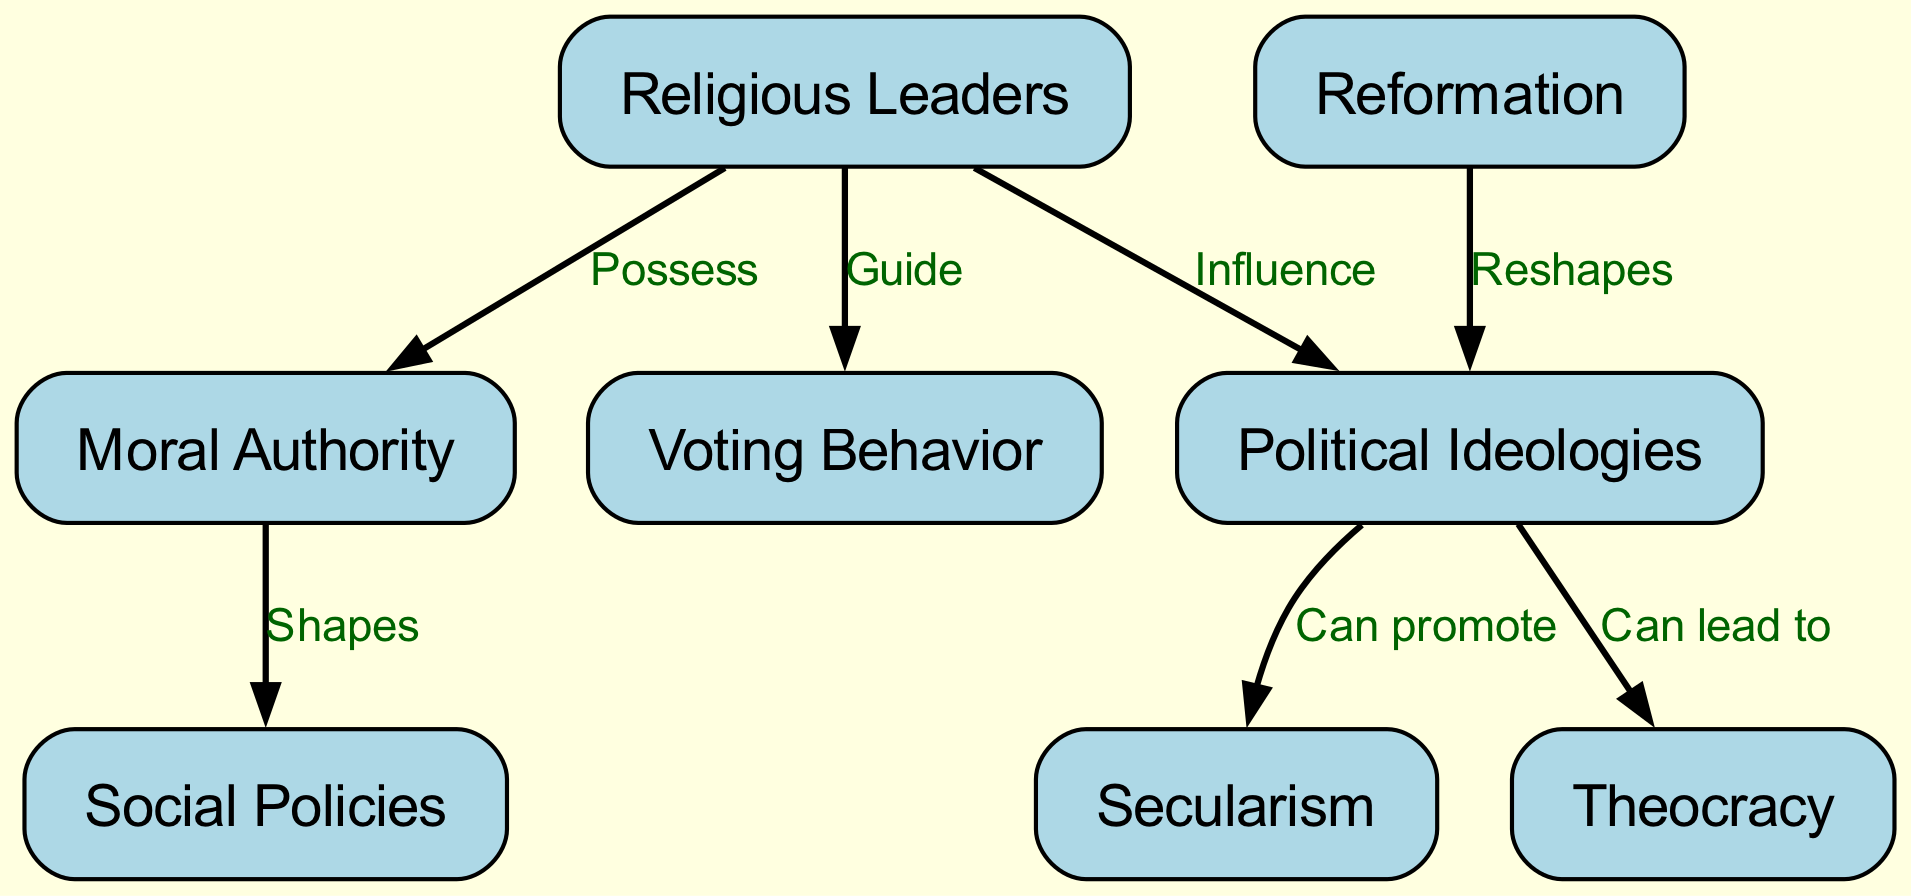What is the main type of influence religious leaders have on political ideologies? The diagram indicates that religious leaders have an "Influence" on political ideologies, showing their ability to shape or direct how ideologies form and evolve within a society.
Answer: Influence How many nodes are present in the diagram? Counting the nodes listed, there are 8 distinct entities represented in the diagram.
Answer: 8 Which political ideology can lead to theocracy? The diagram clearly illustrates that one of the political ideologies is theocracy, linked by the label "Can lead to" from the political ideologies node.
Answer: Theocracy What do religious leaders possess according to the diagram? The diagram explicitly states that religious leaders "Possess" moral authority, indicating their recognized status and influence in ethical and governance discussions.
Answer: Moral Authority How do moral authority and social policies relate? The arrow between "Moral Authority" and "Social Policies" labeled "Shapes" indicates that moral authority can influence or determine the nature of social policies in a political context.
Answer: Shapes What role do religious leaders play in voting behavior? According to the diagram, religious leaders "Guide" voting behavior, showcasing their essential impact on how individuals make choices during elections, often aligned with religious values.
Answer: Guide What can political ideologies promote according to the diagram? The diagram shows that political ideologies can promote secularism, indicating a tendency toward separating religious influence from governance matters.
Answer: Secularism How does reformation affect political ideologies? The link labeled "Reshapes" from the reformation to political ideologies signifies that the process of reformation can fundamentally change or redefine political ideologies over time.
Answer: Reshapes 